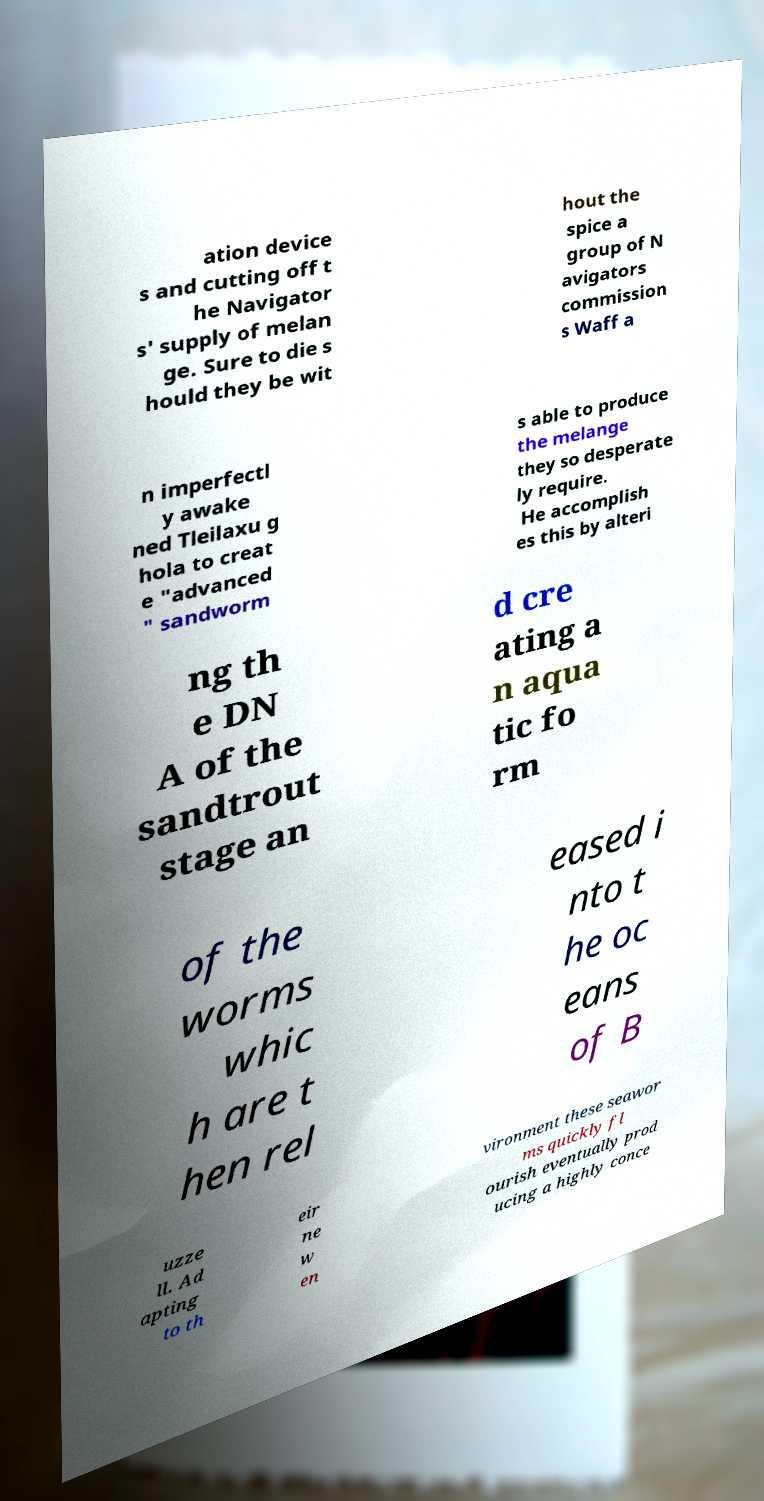Could you extract and type out the text from this image? ation device s and cutting off t he Navigator s' supply of melan ge. Sure to die s hould they be wit hout the spice a group of N avigators commission s Waff a n imperfectl y awake ned Tleilaxu g hola to creat e "advanced " sandworm s able to produce the melange they so desperate ly require. He accomplish es this by alteri ng th e DN A of the sandtrout stage an d cre ating a n aqua tic fo rm of the worms whic h are t hen rel eased i nto t he oc eans of B uzze ll. Ad apting to th eir ne w en vironment these seawor ms quickly fl ourish eventually prod ucing a highly conce 